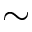Convert formula to latex. <formula><loc_0><loc_0><loc_500><loc_500>\sim</formula> 